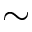Convert formula to latex. <formula><loc_0><loc_0><loc_500><loc_500>\sim</formula> 